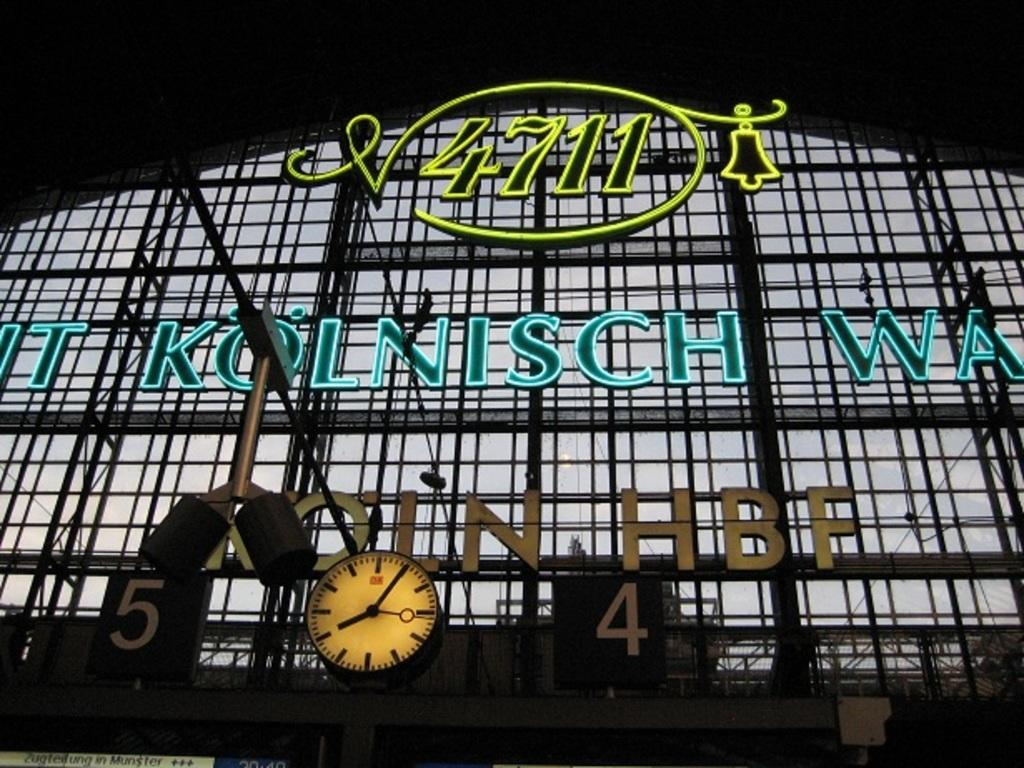What object in the image is used for telling time? There is a clock in the image that is used for telling time. What are the two objects at the bottom of the image? There are two boards at the bottom of the image. What type of material is used for the rods in the image? The rods in the image are made of metal. What can be found in the middle of the image? There is text in the middle of the image. How many fruits are hanging from the metal rods in the image? There are no fruits present in the image; it features a clock, two boards, metal rods, and text. What type of currency is depicted in the text in the middle of the image? There is no mention of currency in the text in the middle of the image. 